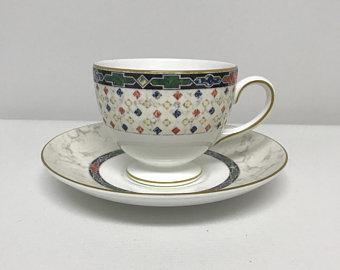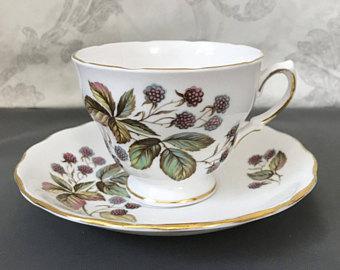The first image is the image on the left, the second image is the image on the right. Evaluate the accuracy of this statement regarding the images: "Both tea cups have curved or curled legs with gold paint.". Is it true? Answer yes or no. No. 